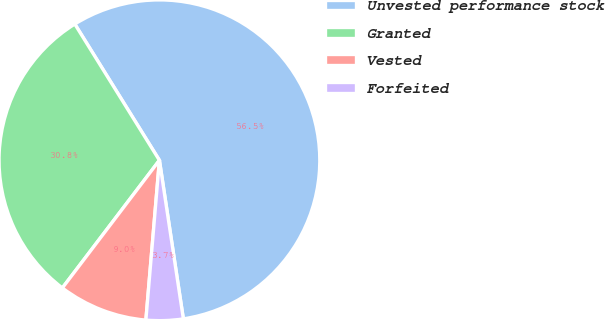Convert chart to OTSL. <chart><loc_0><loc_0><loc_500><loc_500><pie_chart><fcel>Unvested performance stock<fcel>Granted<fcel>Vested<fcel>Forfeited<nl><fcel>56.46%<fcel>30.81%<fcel>9.0%<fcel>3.73%<nl></chart> 